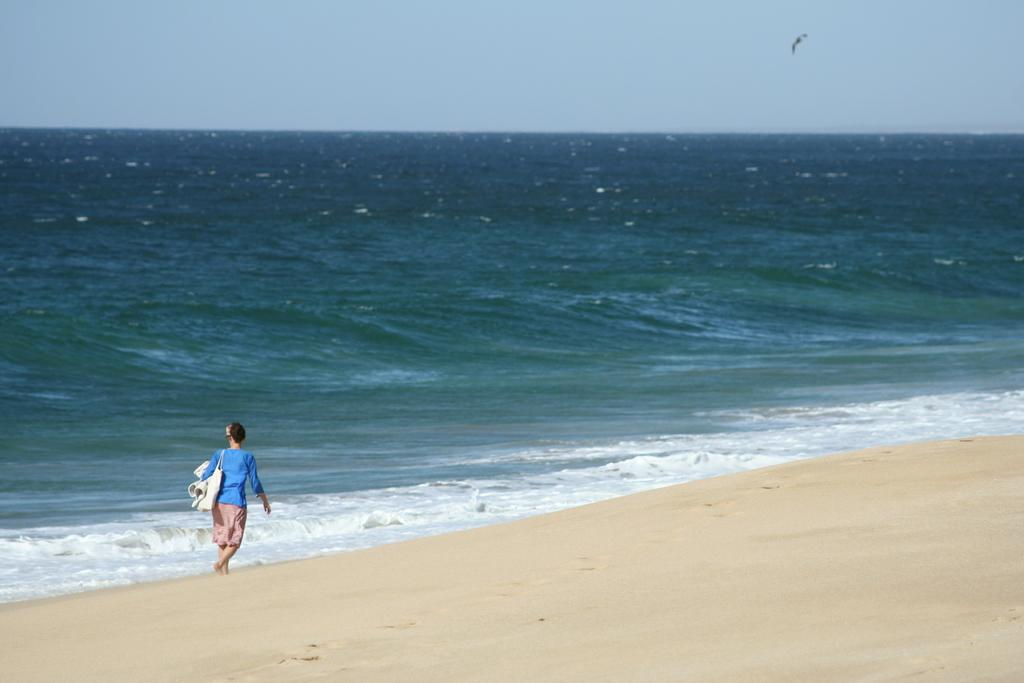Who is present in the image? There is a woman in the image. What is the woman wearing? The woman is wearing a bag. What is the woman holding in the image? The woman is holding a cloth. Where is the woman located in the image? The woman is walking on the seashore. What can be seen in the background of the image? There is a large water body and the sky visible in the image. What is the tax rate for the year depicted in the image? There is no information about the tax rate or the year in the image. How many lizards can be seen on the woman's shoulder in the image? There are no lizards present in the image. 